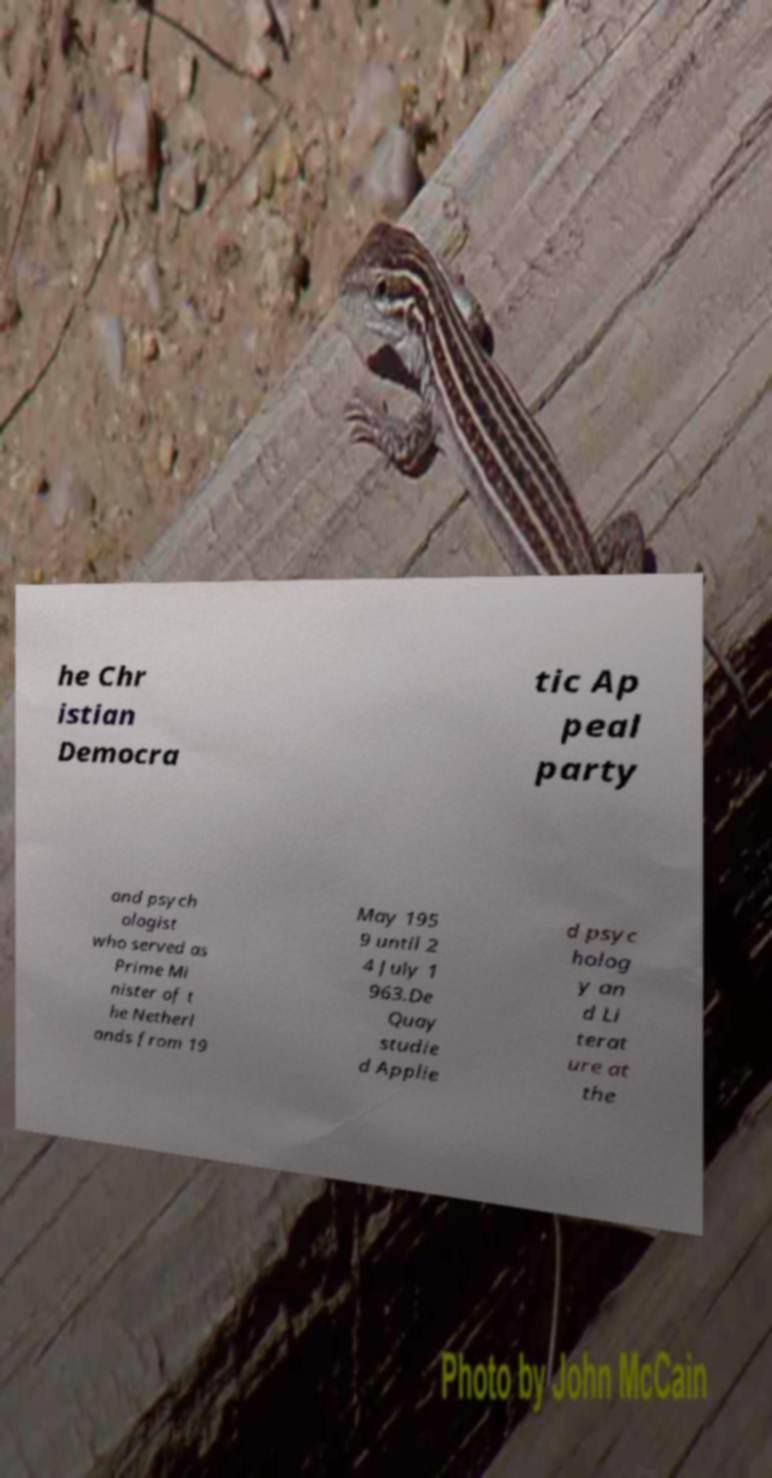Can you read and provide the text displayed in the image?This photo seems to have some interesting text. Can you extract and type it out for me? he Chr istian Democra tic Ap peal party and psych ologist who served as Prime Mi nister of t he Netherl ands from 19 May 195 9 until 2 4 July 1 963.De Quay studie d Applie d psyc holog y an d Li terat ure at the 